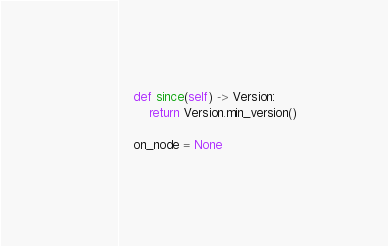<code> <loc_0><loc_0><loc_500><loc_500><_Python_>    def since(self) -> Version:
        return Version.min_version()

    on_node = None
</code> 